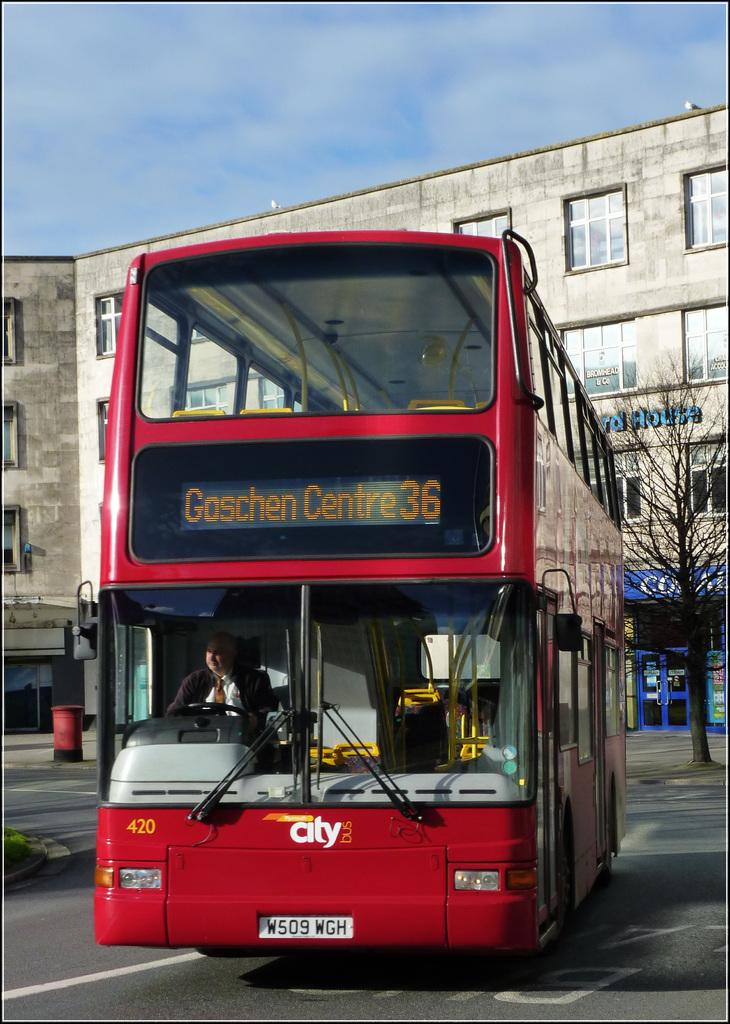<image>
Describe the image concisely. A bus numbered 420 is on the street. 